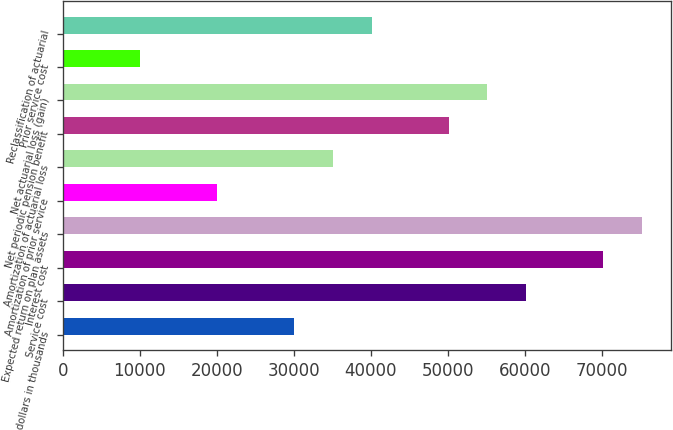Convert chart. <chart><loc_0><loc_0><loc_500><loc_500><bar_chart><fcel>dollars in thousands<fcel>Service cost<fcel>Interest cost<fcel>Expected return on plan assets<fcel>Amortization of prior service<fcel>Amortization of actuarial loss<fcel>Net periodic pension benefit<fcel>Net actuarial loss (gain)<fcel>Prior service cost<fcel>Reclassification of actuarial<nl><fcel>30074.6<fcel>60145.7<fcel>70169.4<fcel>75181.3<fcel>20050.8<fcel>35086.4<fcel>50122<fcel>55133.9<fcel>10027.1<fcel>40098.3<nl></chart> 